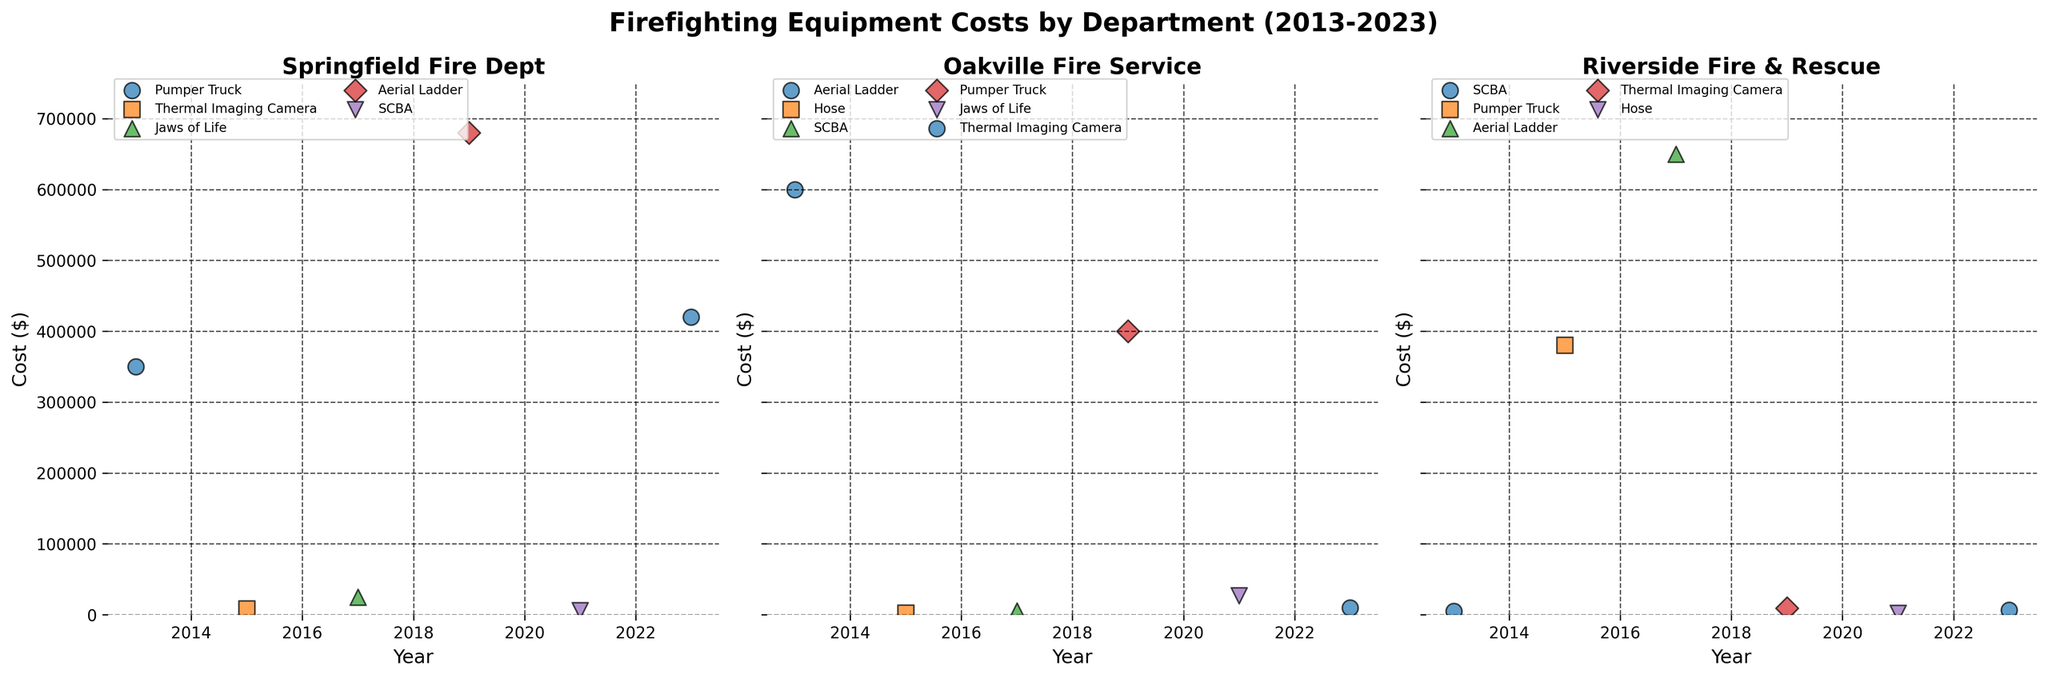What is the title of the figure? The title is located at the top of the figure and provides an overview of the data displayed. Here, the title is "Firefighting Equipment Costs by Department (2013-2023)".
Answer: Firefighting Equipment Costs by Department (2013-2023) How many fire departments are compared in the figure? Each subplot corresponds to one fire department. Here, there are three subplots, so there are three fire departments.
Answer: Three What is the cost of the Aerial Ladder for Springfield Fire Dept in 2019? Locate the subplot for Springfield Fire Dept, then identify the year 2019 on the x-axis and look for the data point corresponding to "Aerial Ladder". Check the y-axis for the cost.
Answer: $680,000 Which department had the highest equipment cost overall, and which equipment was it? Look at all the subplots and identify the data point with the highest y-value. The highest point is in Riverside Fire & Rescue for the "Aerial Ladder" in 2017.
Answer: Riverside Fire & Rescue, Aerial Ladder Which equipment appears most frequently in Oakville Fire Service data points? Count how many times each type of equipment is listed in the subplot for Oakville Fire Service. "Thermal Imaging Camera" appears most frequently in the data.
Answer: Thermal Imaging Camera What is the difference in cost between the Pumper Truck in 2013 and 2023 for Springfield Fire Dept? In the subplot for Springfield Fire Dept, check the y-value for the Pumper Truck in 2013 and 2023. Subtract the 2013 cost from the 2023 cost to get the difference.
Answer: $70,000 How does the cost of SCBA change over the years for Riverside Fire & Rescue? In Riverside Fire & Rescue's subplot, locate the data points for SCBA. Note their year and cost, then compare the costs over time. The costs are $5,000 in 2013, $6,500 in 2023, showing an increase.
Answer: Increases from $5,000 to $6,500 Which equipment had the largest cost increase for Oakville Fire Service, based on the available data? Examine Oakville Fire Service's subplot and compare the cost of each equipment over different years. The "Aerial Ladder" had significant increases, but the precise largest increase needs comparing all changes.
Answer: SCBA, from $5,500 to $6,500 What trends can you observe in the thermal imaging camera costs across all departments? Look at the subplots for each department and track the "Thermal Imaging Camera" costs over the years. For Springfield, the costs increased from $8,000 in 2015 to $10,000 in 2023. The costs for other departments also trend upward.
Answer: Increasing costs Compare the cost of the Jaws of Life between Springfield Fire Dept and Oakville Fire Service in the year they were purchased. Locate the Jaws of Life data points in both subplots. For Springfield Fire Dept in 2017, it cost $25,000. For Oakville Fire Service in 2021, it cost $27,000.
Answer: Oakville Fire Service costs $2,000 more 